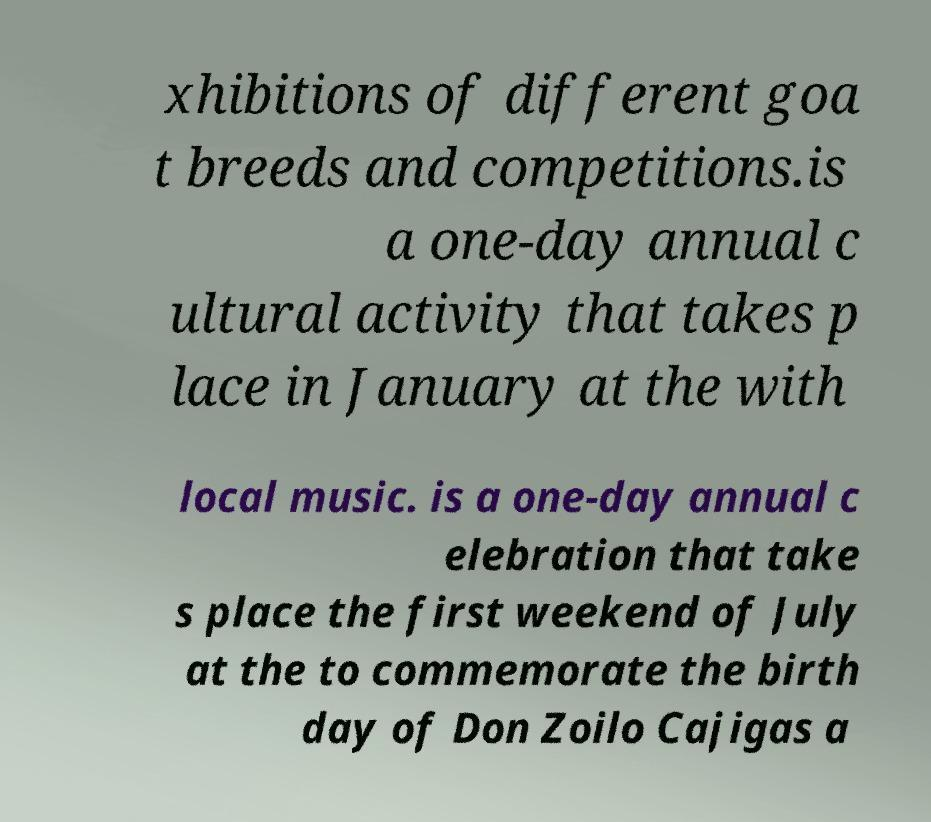Could you extract and type out the text from this image? xhibitions of different goa t breeds and competitions.is a one-day annual c ultural activity that takes p lace in January at the with local music. is a one-day annual c elebration that take s place the first weekend of July at the to commemorate the birth day of Don Zoilo Cajigas a 